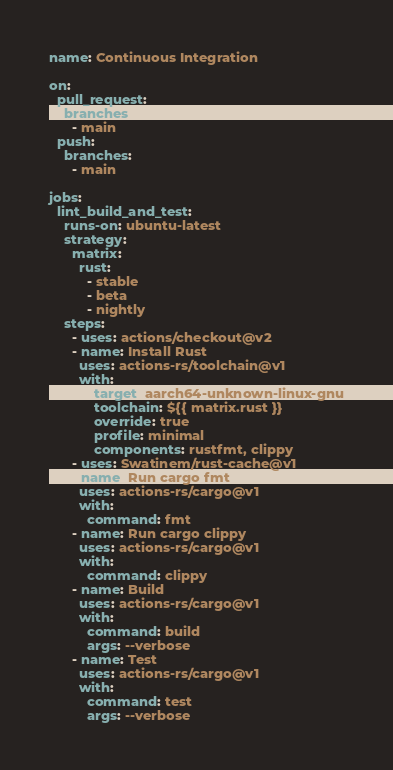<code> <loc_0><loc_0><loc_500><loc_500><_YAML_>name: Continuous Integration

on:
  pull_request:
    branches:
      - main
  push:
    branches:
      - main

jobs:
  lint_build_and_test:
    runs-on: ubuntu-latest
    strategy:
      matrix:
        rust:
          - stable
          - beta
          - nightly
    steps:
      - uses: actions/checkout@v2
      - name: Install Rust
        uses: actions-rs/toolchain@v1
        with:
            target: aarch64-unknown-linux-gnu
            toolchain: ${{ matrix.rust }}
            override: true
            profile: minimal
            components: rustfmt, clippy
      - uses: Swatinem/rust-cache@v1
      - name: Run cargo fmt
        uses: actions-rs/cargo@v1
        with:
          command: fmt
      - name: Run cargo clippy
        uses: actions-rs/cargo@v1
        with:
          command: clippy
      - name: Build
        uses: actions-rs/cargo@v1
        with:
          command: build
          args: --verbose
      - name: Test
        uses: actions-rs/cargo@v1
        with:
          command: test
          args: --verbose
</code> 